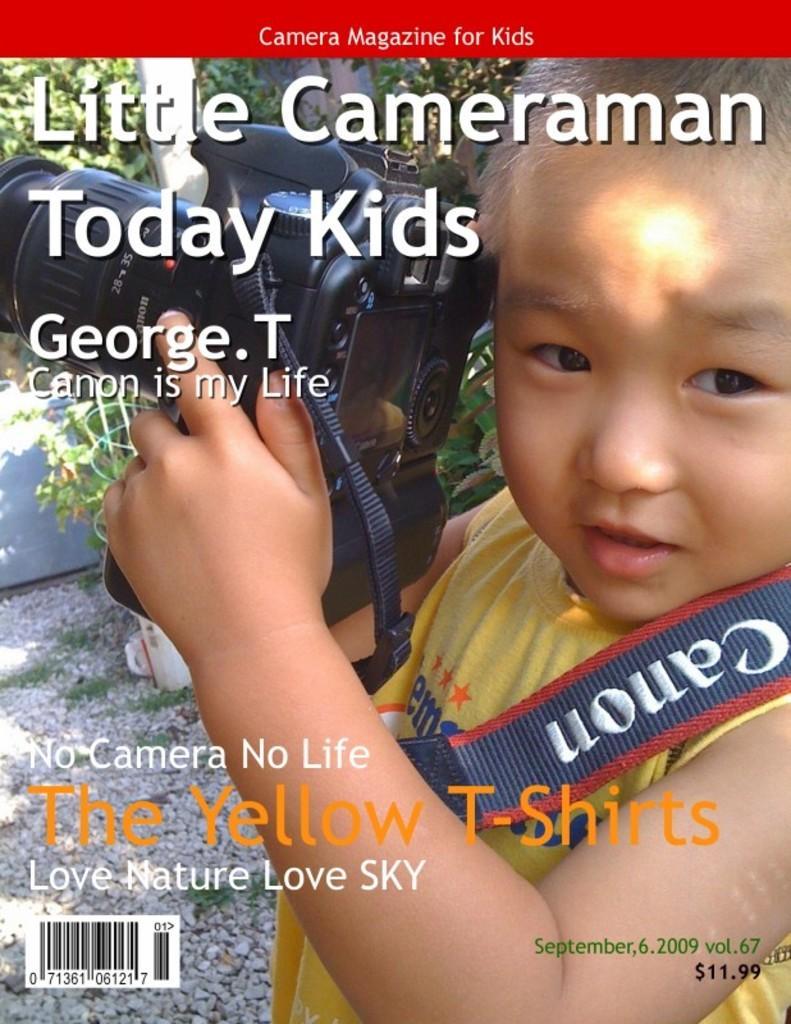Could you give a brief overview of what you see in this image? In this image I can see a child holding the camera. He is wearing yellow and blue color t-shirt. Back Side I can see trees. 